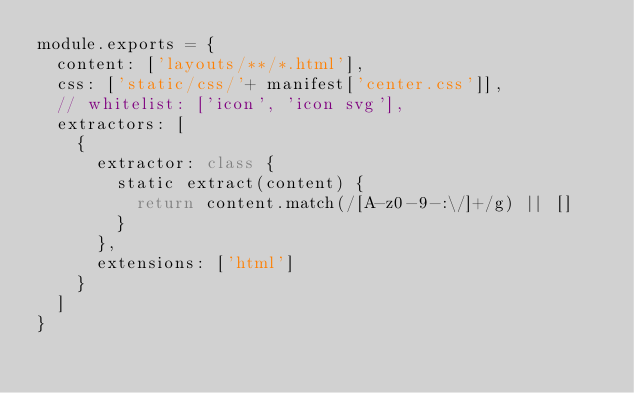Convert code to text. <code><loc_0><loc_0><loc_500><loc_500><_JavaScript_>module.exports = {
  content: ['layouts/**/*.html'],
  css: ['static/css/'+ manifest['center.css']],
  // whitelist: ['icon', 'icon svg'],
  extractors: [
    {
      extractor: class {
        static extract(content) {
          return content.match(/[A-z0-9-:\/]+/g) || []
        }
      },
      extensions: ['html']
    }
  ]
}
</code> 